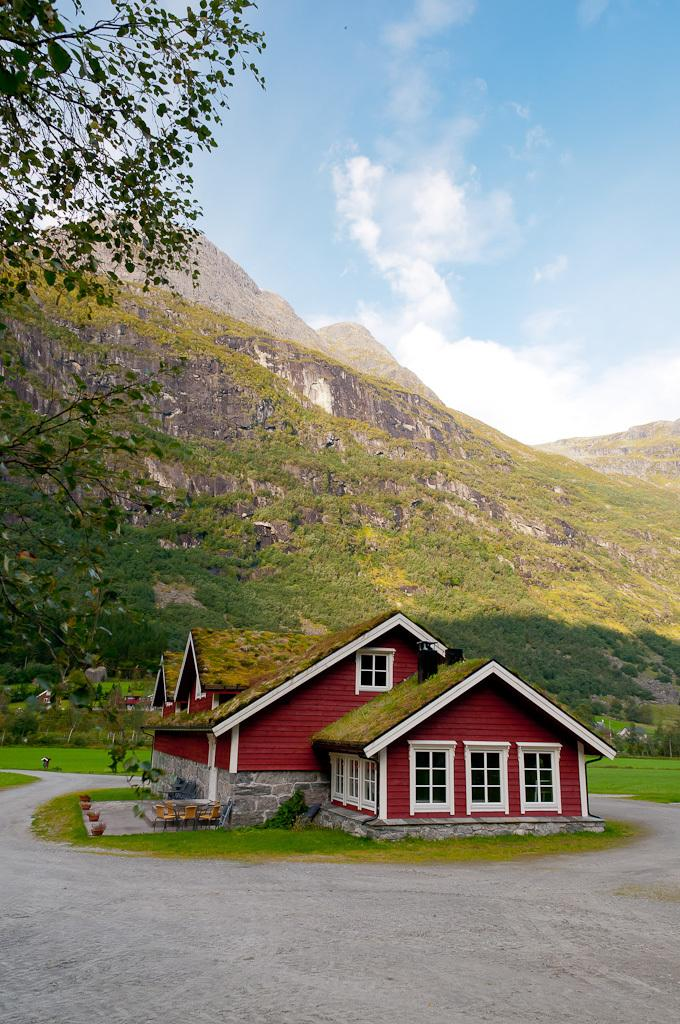What type of building is in the image? There is a house in the image. What can be seen inside the house? There are house plants and flower pots visible in the image. What type of furniture is in the image? There are chairs in the image. What part of the house is visible in the image? There is a window in the image. What is visible in the background of the image? Mountains and trees are visible behind the house, and the sky is visible in the image. What type of mouth can be seen on the snake in the image? There is no snake present in the image, so there is no mouth to observe. 